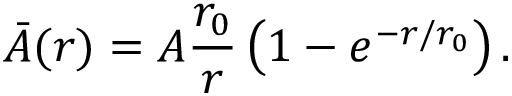<formula> <loc_0><loc_0><loc_500><loc_500>\bar { A } ( r ) = A \frac { r _ { 0 } } { r } \left ( 1 - e ^ { - r / r _ { 0 } } \right ) .</formula> 